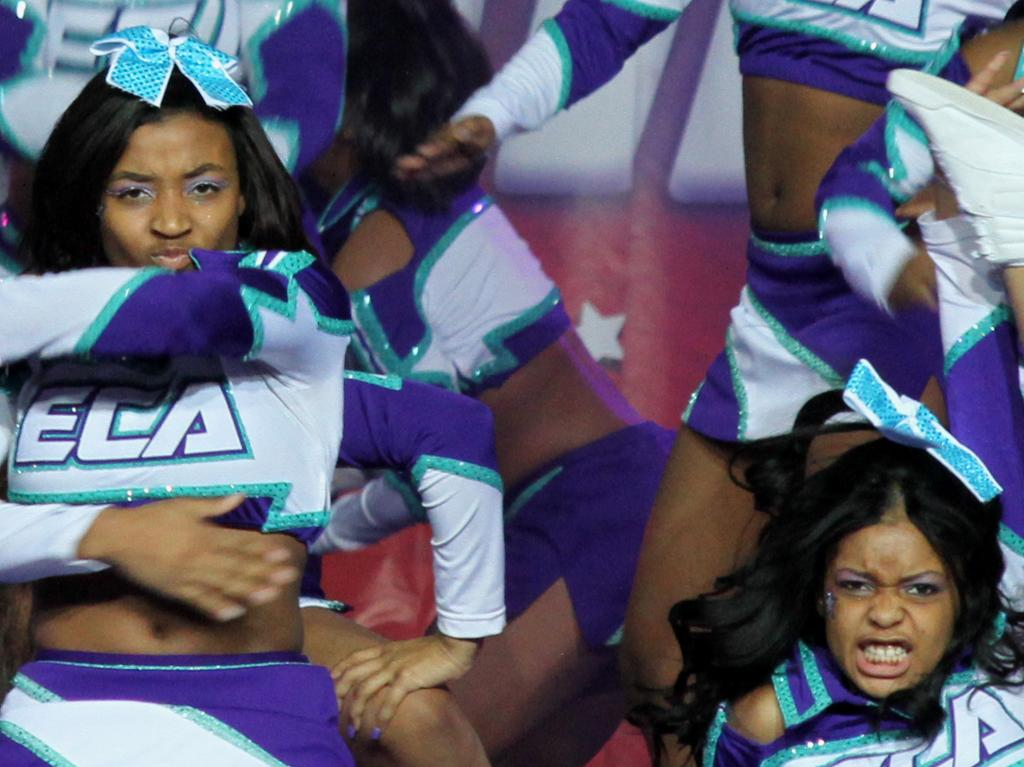<image>
Give a short and clear explanation of the subsequent image. A group of cheerleaders with ECA on their uniforms. 